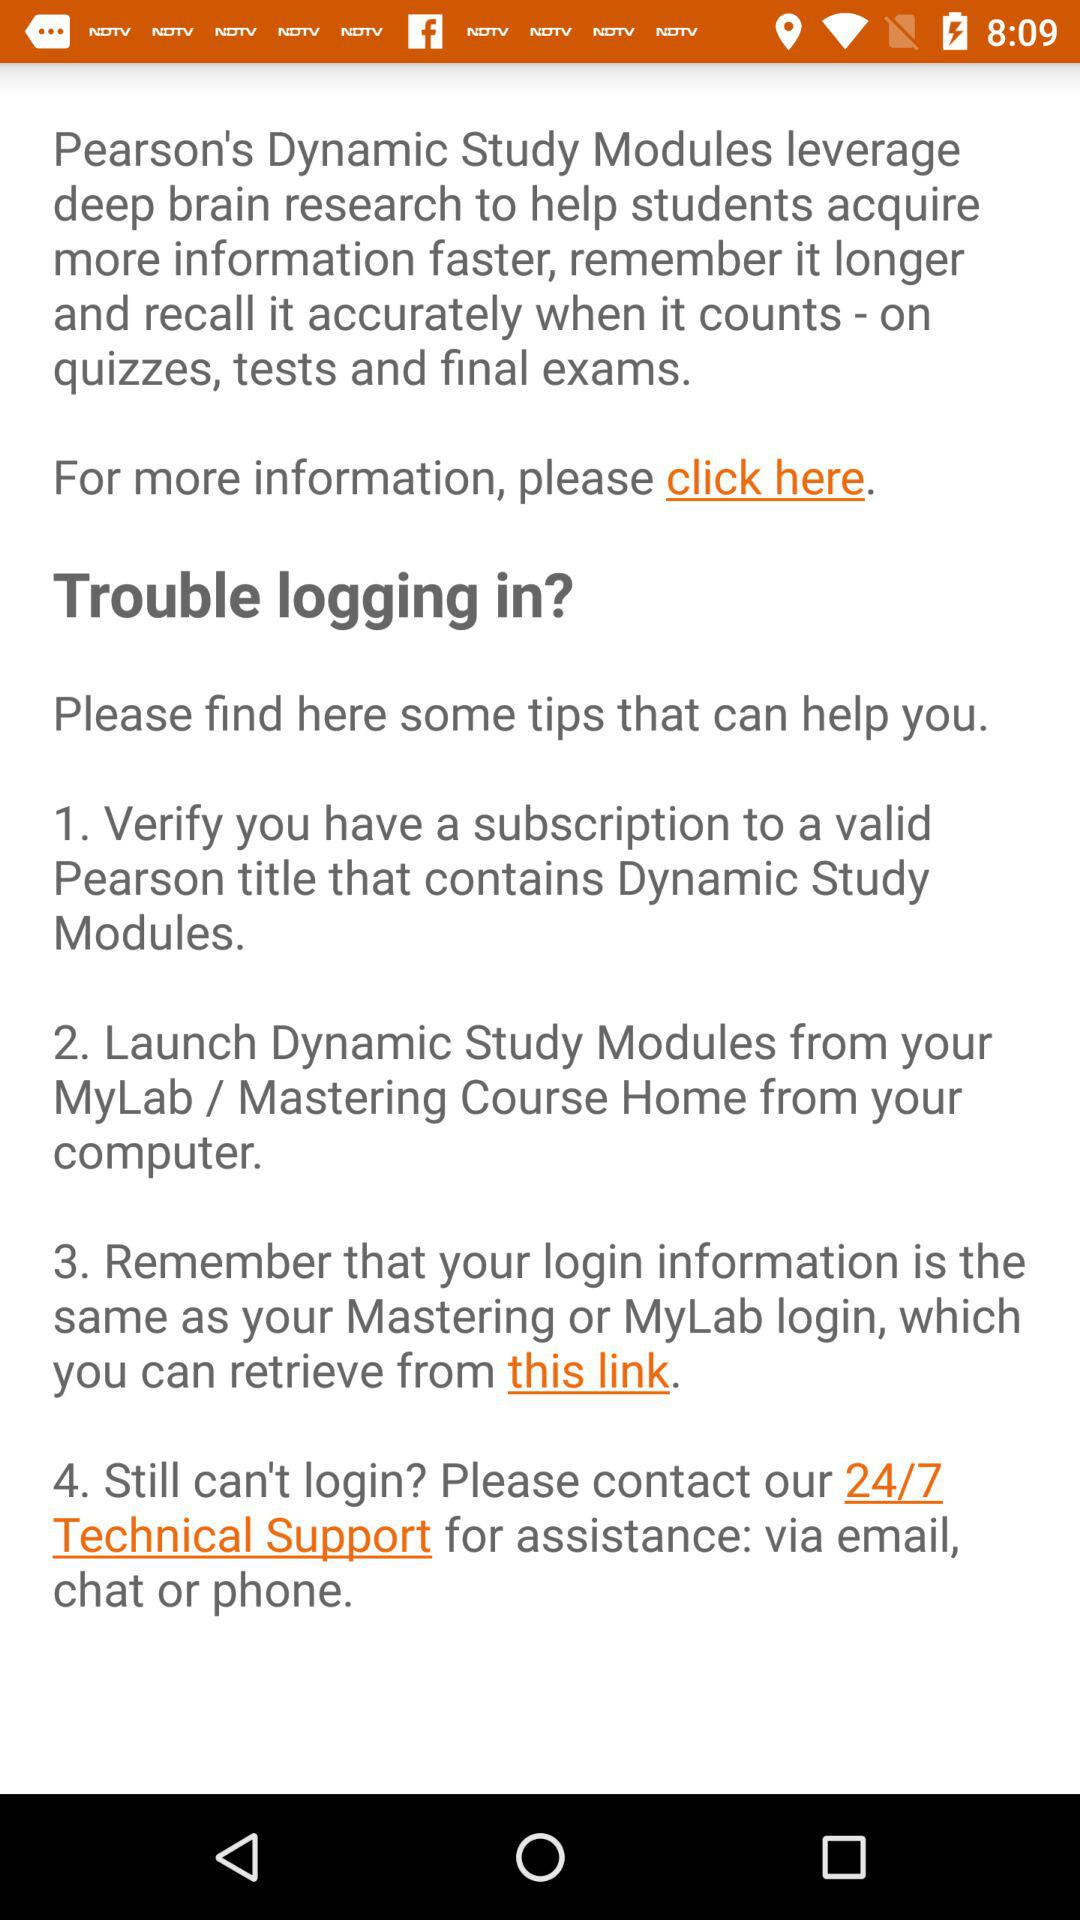How many tips are provided to help students troubleshoot logging in?
Answer the question using a single word or phrase. 4 